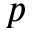Convert formula to latex. <formula><loc_0><loc_0><loc_500><loc_500>p</formula> 